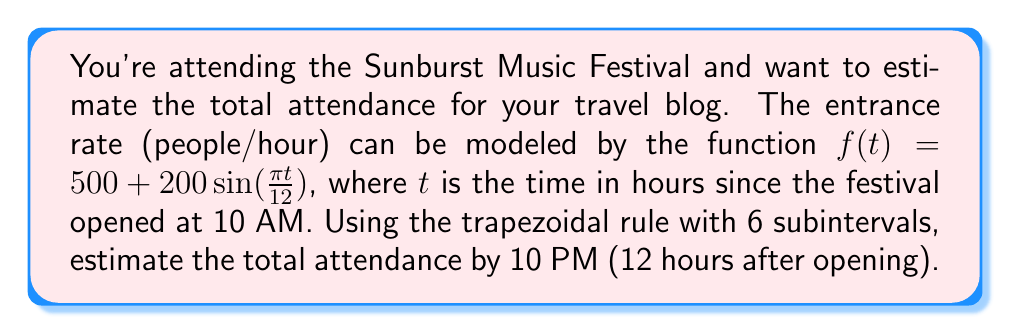Can you answer this question? 1) The trapezoidal rule for numerical integration is given by:

   $$\int_{a}^{b} f(x)dx \approx \frac{h}{2}[f(x_0) + 2f(x_1) + 2f(x_2) + ... + 2f(x_{n-1}) + f(x_n)]$$

   where $h = \frac{b-a}{n}$, $n$ is the number of subintervals, and $x_i = a + ih$.

2) In this case, $a=0$, $b=12$, and $n=6$. So, $h = \frac{12-0}{6} = 2$.

3) Calculate $f(t)$ at each point:
   $f(0) = 500 + 200\sin(0) = 500$
   $f(2) = 500 + 200\sin(\frac{\pi}{6}) \approx 600$
   $f(4) = 500 + 200\sin(\frac{\pi}{3}) \approx 673.2$
   $f(6) = 500 + 200\sin(\frac{\pi}{2}) = 700$
   $f(8) = 500 + 200\sin(\frac{2\pi}{3}) \approx 673.2$
   $f(10) = 500 + 200\sin(\frac{5\pi}{6}) \approx 600$
   $f(12) = 500 + 200\sin(\pi) = 500$

4) Apply the trapezoidal rule:
   $$\text{Attendance} \approx \frac{2}{2}[500 + 2(600) + 2(673.2) + 2(700) + 2(673.2) + 2(600) + 500]$$
   $$= 1[500 + 1200 + 1346.4 + 1400 + 1346.4 + 1200 + 500]$$
   $$= 7492.8$$

5) Round to the nearest whole number as we can't have fractional attendees.
Answer: 7493 people 